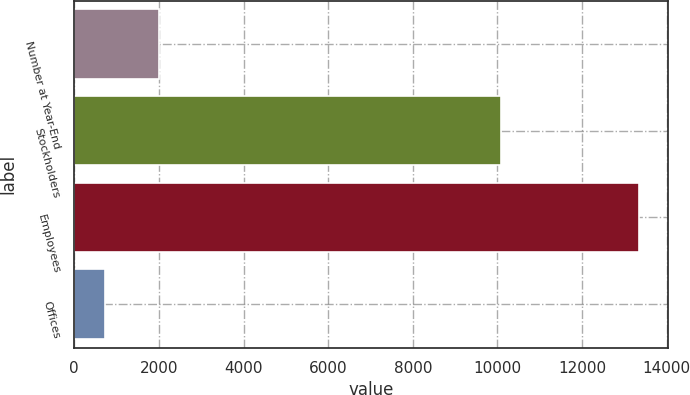Convert chart to OTSL. <chart><loc_0><loc_0><loc_500><loc_500><bar_chart><fcel>Number at Year-End<fcel>Stockholders<fcel>Employees<fcel>Offices<nl><fcel>2006<fcel>10084<fcel>13352<fcel>736<nl></chart> 